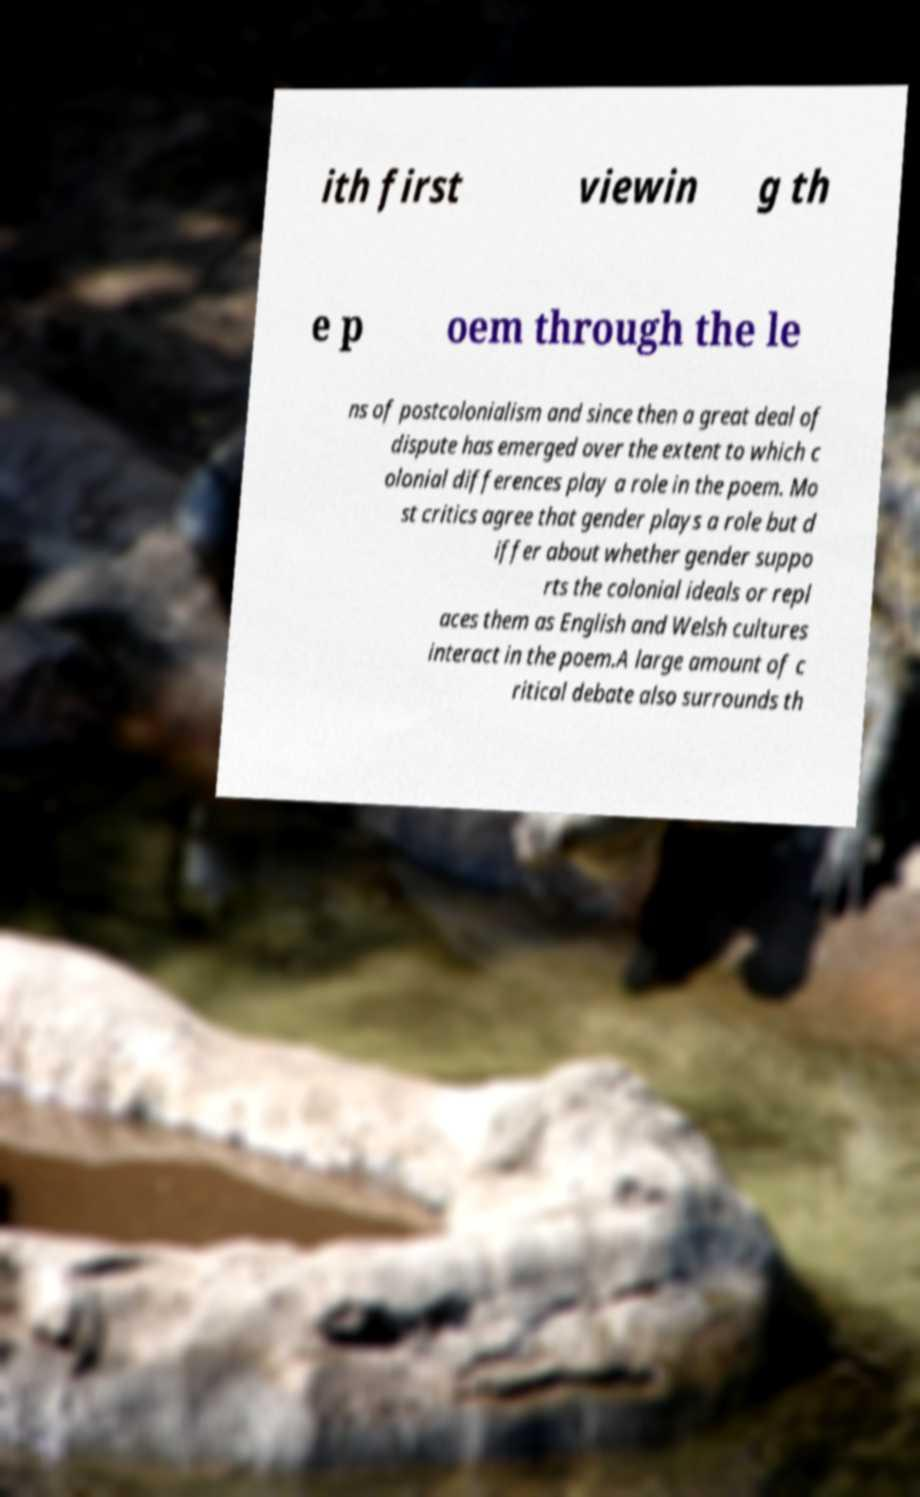Can you accurately transcribe the text from the provided image for me? ith first viewin g th e p oem through the le ns of postcolonialism and since then a great deal of dispute has emerged over the extent to which c olonial differences play a role in the poem. Mo st critics agree that gender plays a role but d iffer about whether gender suppo rts the colonial ideals or repl aces them as English and Welsh cultures interact in the poem.A large amount of c ritical debate also surrounds th 